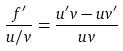Convert formula to latex. <formula><loc_0><loc_0><loc_500><loc_500>\frac { f ^ { \prime } } { u / v } = \frac { u ^ { \prime } v - u v ^ { \prime } } { u v }</formula> 